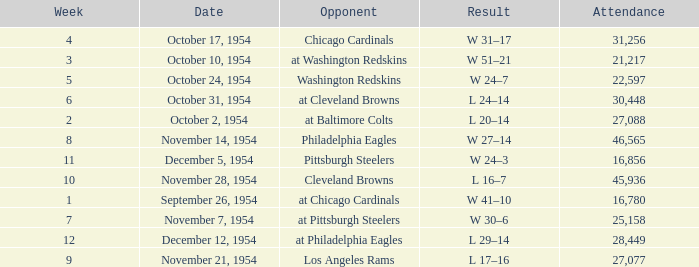How many weeks have october 31, 1954 as the date? 1.0. 